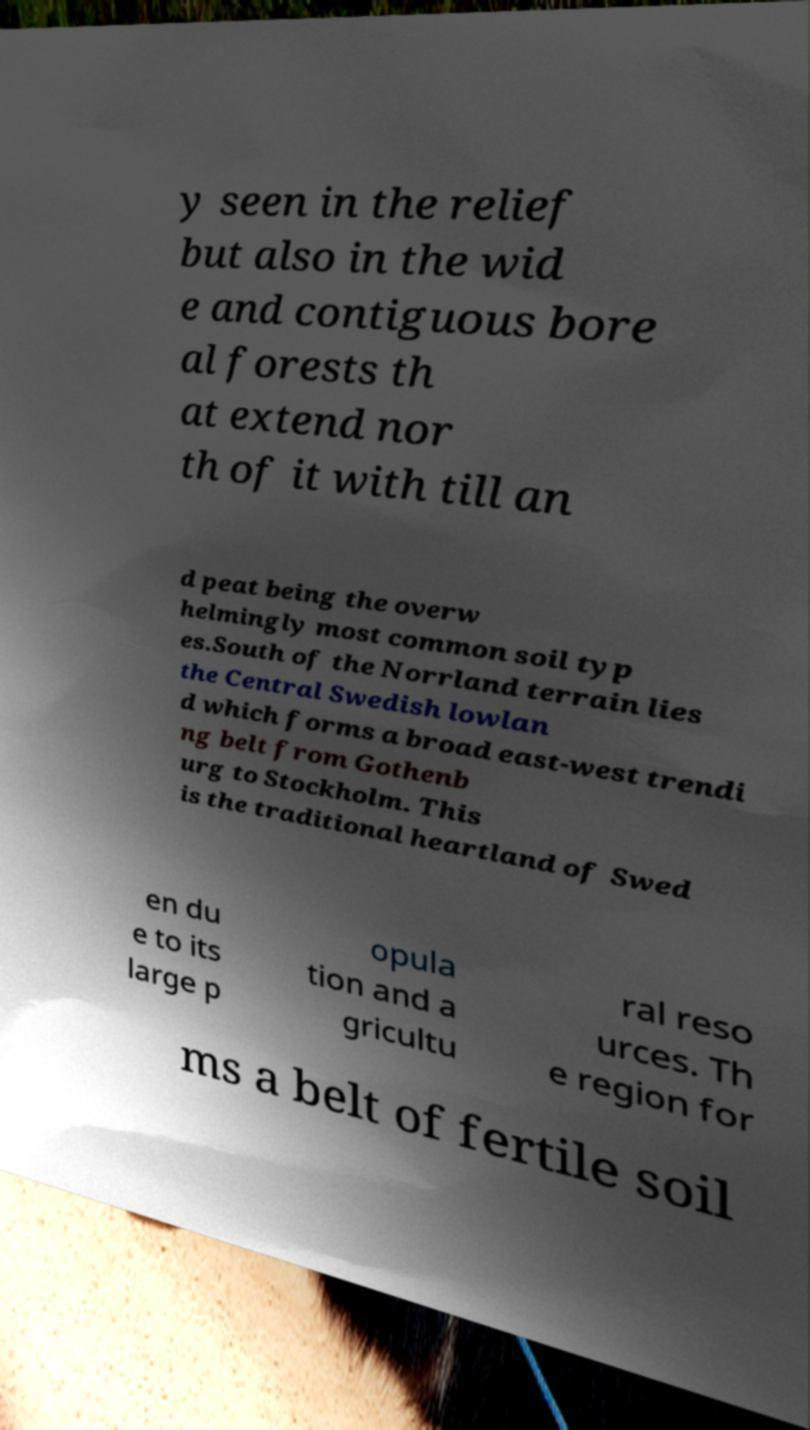What messages or text are displayed in this image? I need them in a readable, typed format. y seen in the relief but also in the wid e and contiguous bore al forests th at extend nor th of it with till an d peat being the overw helmingly most common soil typ es.South of the Norrland terrain lies the Central Swedish lowlan d which forms a broad east-west trendi ng belt from Gothenb urg to Stockholm. This is the traditional heartland of Swed en du e to its large p opula tion and a gricultu ral reso urces. Th e region for ms a belt of fertile soil 